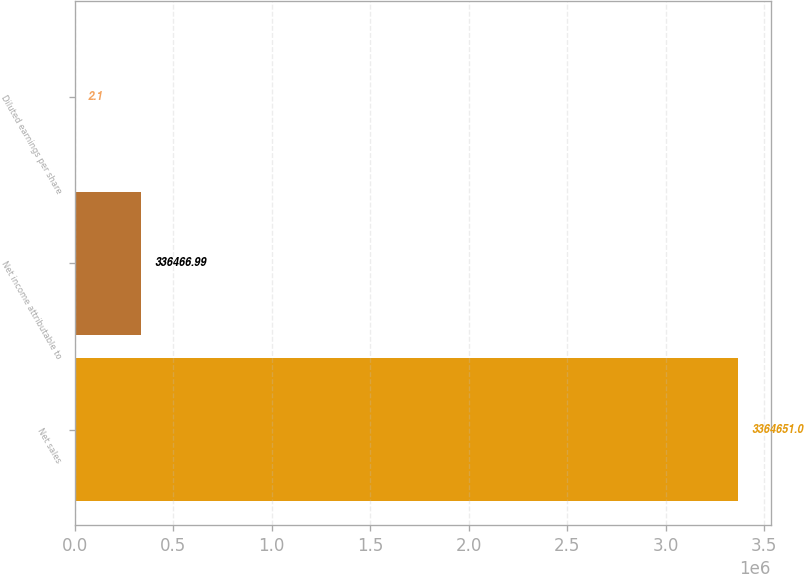<chart> <loc_0><loc_0><loc_500><loc_500><bar_chart><fcel>Net sales<fcel>Net income attributable to<fcel>Diluted earnings per share<nl><fcel>3.36465e+06<fcel>336467<fcel>2.1<nl></chart> 